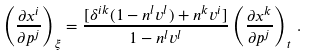Convert formula to latex. <formula><loc_0><loc_0><loc_500><loc_500>\left ( \frac { \partial x ^ { i } } { \partial p ^ { j } } \right ) _ { \xi } = \frac { [ \delta ^ { i k } ( 1 - n ^ { l } v ^ { l } ) + n ^ { k } v ^ { i } ] } { 1 - n ^ { l } v ^ { l } } \left ( \frac { \partial x ^ { k } } { \partial p ^ { j } } \right ) _ { t } \, .</formula> 